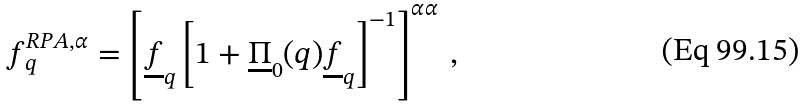Convert formula to latex. <formula><loc_0><loc_0><loc_500><loc_500>f ^ { R P A , \alpha } _ { q } = \left [ \underline { f } _ { q } \left [ 1 + \underline { \Pi } _ { 0 } ( q ) \underline { f } _ { q } \right ] ^ { - 1 } \right ] ^ { \alpha \alpha } \, ,</formula> 